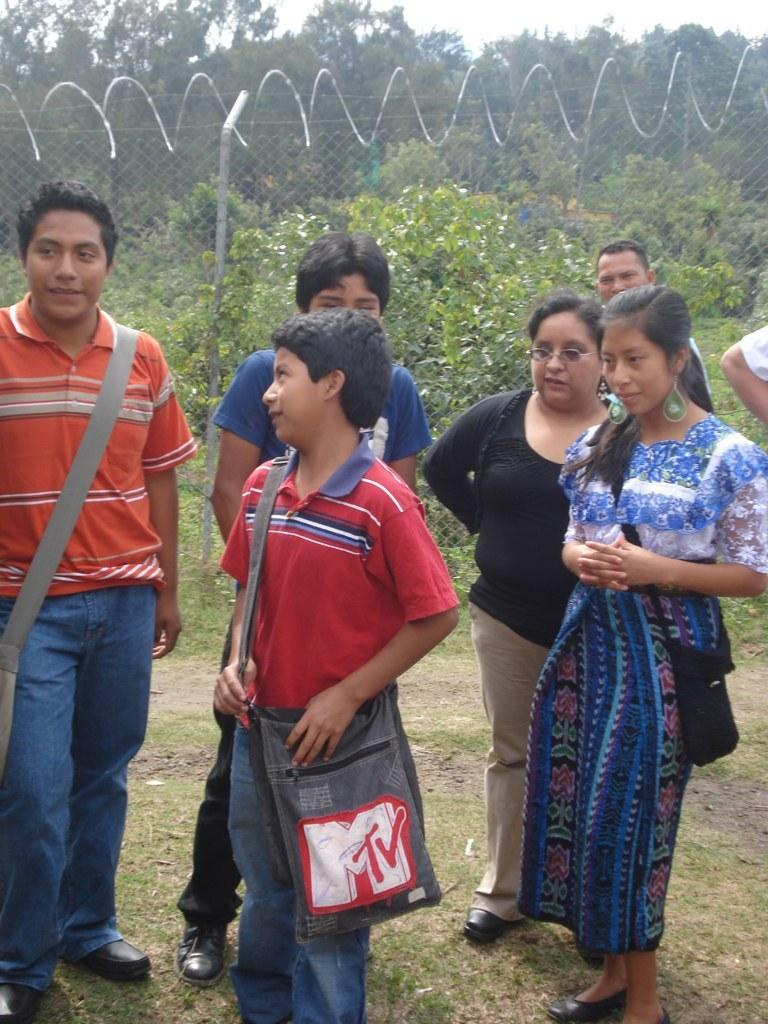What type of natural elements are present in the image? There are trees and plants in the image. Can you describe the people in the image? There are people in the image, and they are wearing clothes. What is the location of the people in relation to the metal fence? The people are standing in front of a metal fence. How can the people in the image help fold the clothes? There is no indication of clothes being folded in the image, nor is there any mention of the people helping with folding. 